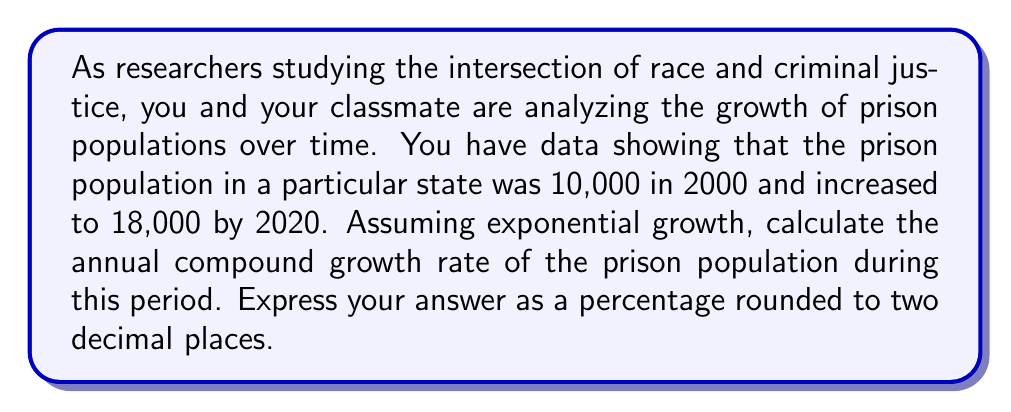Can you answer this question? To solve this problem, we'll use the compound interest formula and solve for the growth rate:

$$A = P(1 + r)^t$$

Where:
$A$ = Final amount (18,000)
$P$ = Initial amount (10,000)
$r$ = Annual growth rate (what we're solving for)
$t$ = Time period in years (20)

Let's solve this step-by-step:

1) Substitute the known values into the equation:
   $$18000 = 10000(1 + r)^{20}$$

2) Divide both sides by 10000:
   $$1.8 = (1 + r)^{20}$$

3) Take the 20th root of both sides:
   $$\sqrt[20]{1.8} = 1 + r$$

4) Subtract 1 from both sides:
   $$\sqrt[20]{1.8} - 1 = r$$

5) Calculate the value:
   $$r \approx 0.0298$$

6) Convert to a percentage:
   $$r \approx 2.98\%$$

Therefore, the annual compound growth rate is approximately 2.98%.

Note: This calculation assumes a constant growth rate, which may not reflect real-world complexities in criminal justice policies and demographics over time.
Answer: 2.98% 